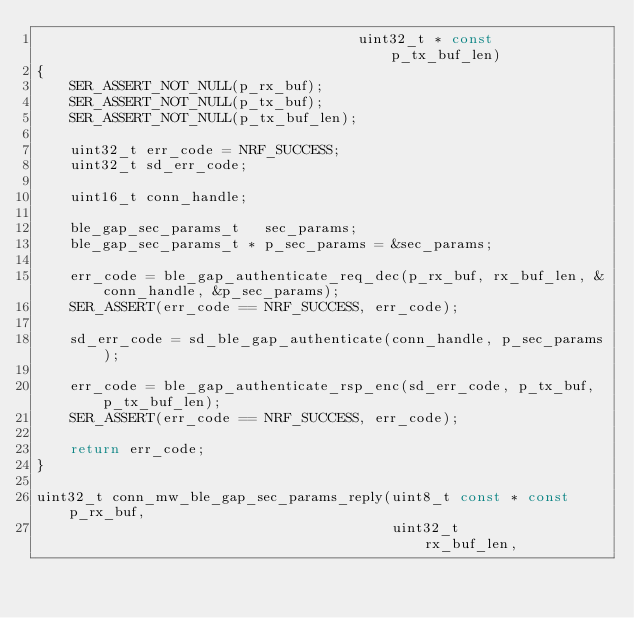Convert code to text. <code><loc_0><loc_0><loc_500><loc_500><_C_>                                      uint32_t * const      p_tx_buf_len)
{
    SER_ASSERT_NOT_NULL(p_rx_buf);
    SER_ASSERT_NOT_NULL(p_tx_buf);
    SER_ASSERT_NOT_NULL(p_tx_buf_len);

    uint32_t err_code = NRF_SUCCESS;
    uint32_t sd_err_code;

    uint16_t conn_handle;

    ble_gap_sec_params_t   sec_params;
    ble_gap_sec_params_t * p_sec_params = &sec_params;

    err_code = ble_gap_authenticate_req_dec(p_rx_buf, rx_buf_len, &conn_handle, &p_sec_params);
    SER_ASSERT(err_code == NRF_SUCCESS, err_code);

    sd_err_code = sd_ble_gap_authenticate(conn_handle, p_sec_params);

    err_code = ble_gap_authenticate_rsp_enc(sd_err_code, p_tx_buf, p_tx_buf_len);
    SER_ASSERT(err_code == NRF_SUCCESS, err_code);

    return err_code;
}

uint32_t conn_mw_ble_gap_sec_params_reply(uint8_t const * const p_rx_buf,
                                          uint32_t              rx_buf_len,</code> 